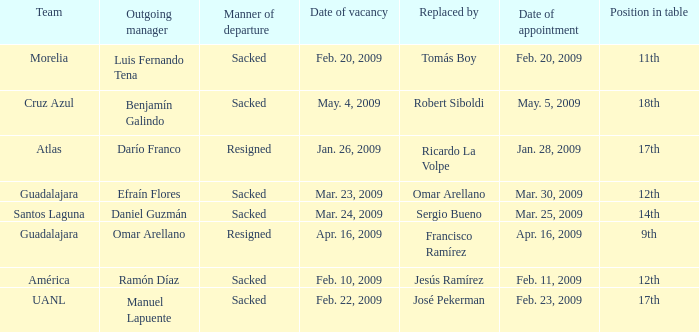What is Position in Table, when Replaced By is "Sergio Bueno"? 14th. 